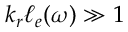Convert formula to latex. <formula><loc_0><loc_0><loc_500><loc_500>k _ { r } \ell _ { e } ( \omega ) \gg 1</formula> 